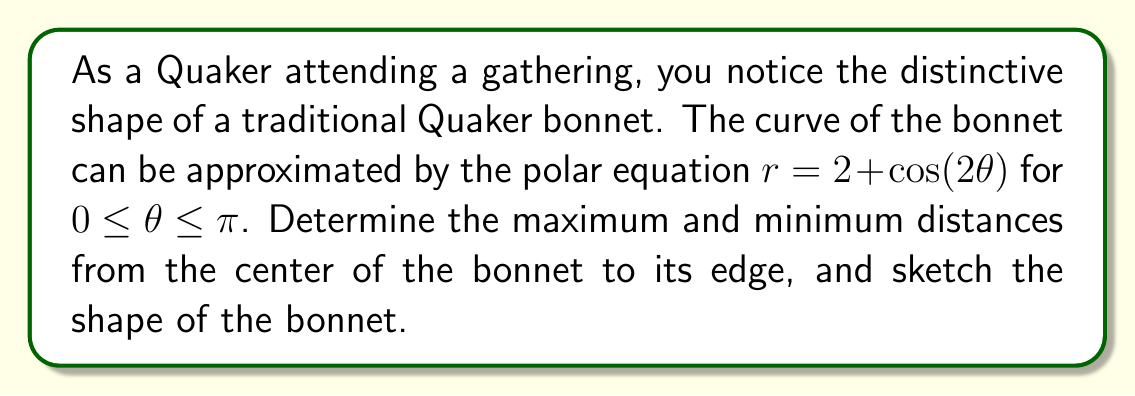Solve this math problem. To analyze the shape of the Quaker bonnet using the given polar equation, we'll follow these steps:

1) The equation is given as $r = 2 + \cos(2\theta)$ for $0 \leq \theta \leq \pi$.

2) To find the maximum and minimum distances, we need to determine the extreme values of $r$:

   $r = 2 + \cos(2\theta)$
   
   The maximum value of cosine is 1, and the minimum is -1.

3) Maximum distance:
   $r_{max} = 2 + 1 = 3$
   This occurs when $\cos(2\theta) = 1$, which happens at $\theta = 0$ and $\theta = \pi$.

4) Minimum distance:
   $r_{min} = 2 - 1 = 1$
   This occurs when $\cos(2\theta) = -1$, which happens at $\theta = \frac{\pi}{2}$.

5) To sketch the shape, we can plot a few key points:

   At $\theta = 0$ and $\theta = \pi$: $r = 3$
   At $\theta = \frac{\pi}{2}$: $r = 1$
   At $\theta = \frac{\pi}{4}$ and $\theta = \frac{3\pi}{4}$: $r = 2$ (since $\cos(\frac{\pi}{2}) = 0$)

6) The resulting shape will be symmetric about the polar axis and will resemble a figure-eight or a peanut shape, which is characteristic of the curve known as a limacon.

[asy]
import graph;
size(200);

real r(real t) {return 2+cos(2t);}
draw(polargraph(r,0,pi,operator ..),blue);

draw(scale(3)*unitcircle,dashed);
draw(scale(1)*unitcircle,dashed);

label("$r=3$", (3,0), E);
label("$r=1$", (1,0), W);
label("$\theta=0$", (3.2,0), E);
label("$\theta=\frac{\pi}{2}$", (0,1.2), N);
label("$\theta=\pi$", (-3.2,0), W);

dot((3,0));
dot((-3,0));
dot((0,1));
[/asy]

This shape approximates the curved silhouette of a traditional Quaker bonnet when viewed from the side.
Answer: The maximum distance from the center to the edge of the bonnet is 3 units, occurring at $\theta = 0$ and $\theta = \pi$. The minimum distance is 1 unit, occurring at $\theta = \frac{\pi}{2}$. The shape of the bonnet resembles a limacon, symmetric about the polar axis. 